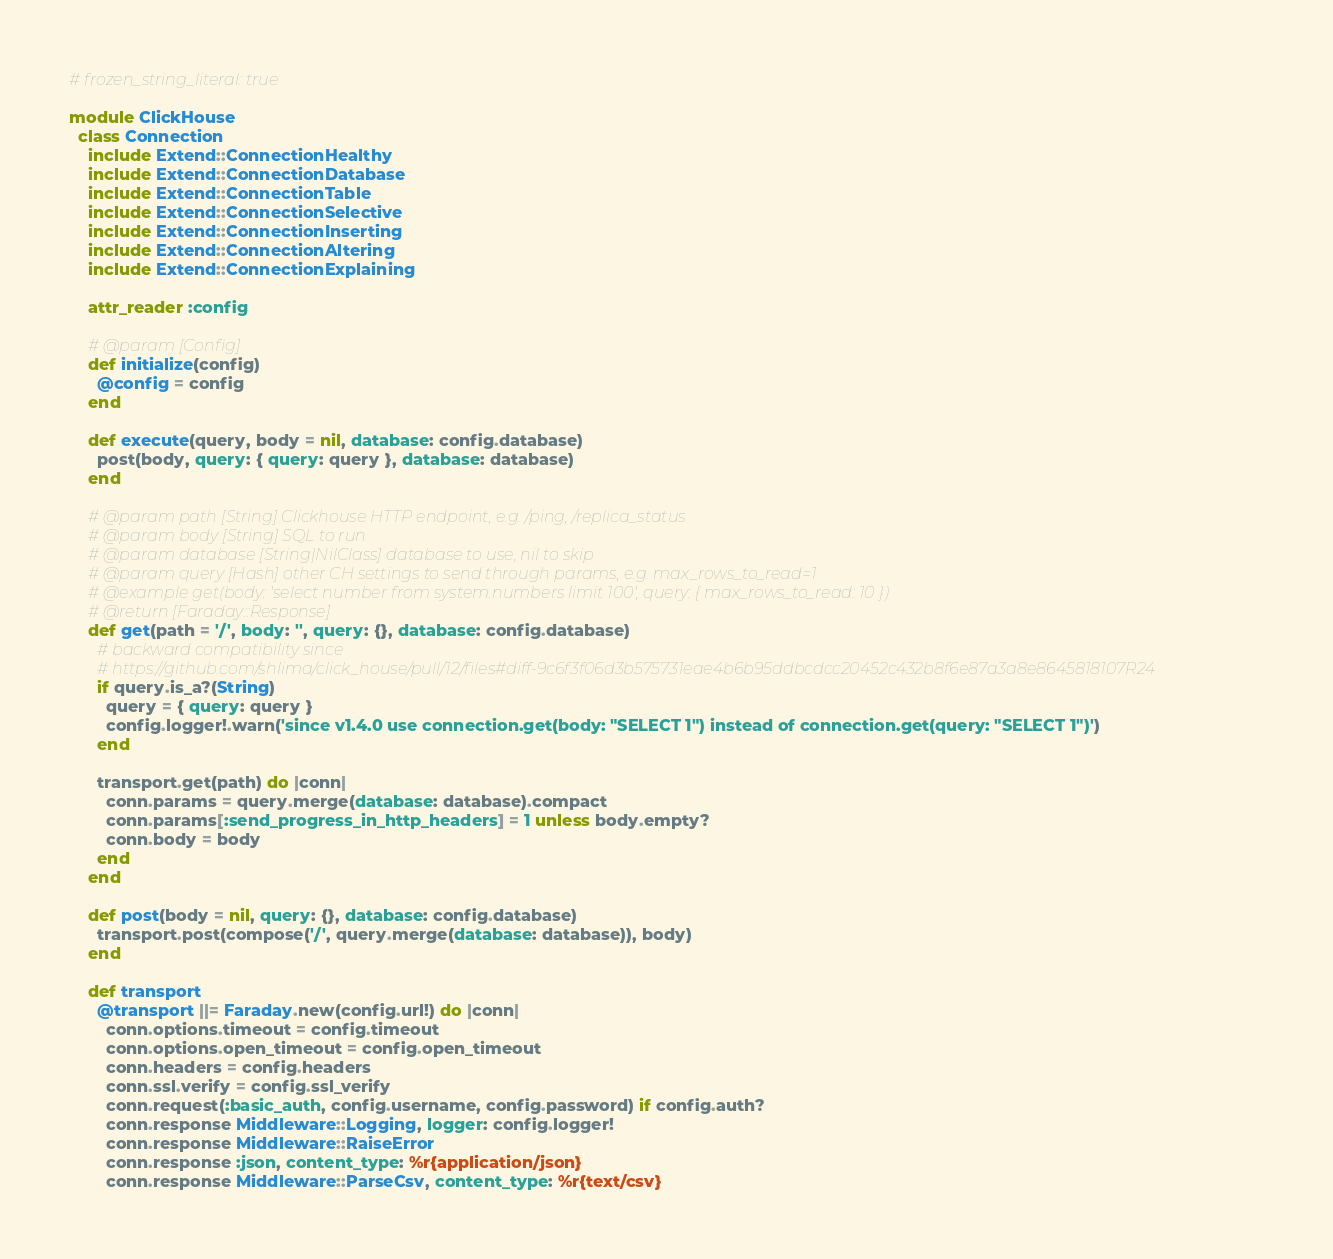<code> <loc_0><loc_0><loc_500><loc_500><_Ruby_># frozen_string_literal: true

module ClickHouse
  class Connection
    include Extend::ConnectionHealthy
    include Extend::ConnectionDatabase
    include Extend::ConnectionTable
    include Extend::ConnectionSelective
    include Extend::ConnectionInserting
    include Extend::ConnectionAltering
    include Extend::ConnectionExplaining

    attr_reader :config

    # @param [Config]
    def initialize(config)
      @config = config
    end

    def execute(query, body = nil, database: config.database)
      post(body, query: { query: query }, database: database)
    end

    # @param path [String] Clickhouse HTTP endpoint, e.g. /ping, /replica_status
    # @param body [String] SQL to run
    # @param database [String|NilClass] database to use, nil to skip
    # @param query [Hash] other CH settings to send through params, e.g. max_rows_to_read=1
    # @example get(body: 'select number from system.numbers limit 100', query: { max_rows_to_read: 10 })
    # @return [Faraday::Response]
    def get(path = '/', body: '', query: {}, database: config.database)
      # backward compatibility since
      # https://github.com/shlima/click_house/pull/12/files#diff-9c6f3f06d3b575731eae4b6b95ddbcdcc20452c432b8f6e87a3a8e8645818107R24
      if query.is_a?(String)
        query = { query: query }
        config.logger!.warn('since v1.4.0 use connection.get(body: "SELECT 1") instead of connection.get(query: "SELECT 1")')
      end

      transport.get(path) do |conn|
        conn.params = query.merge(database: database).compact
        conn.params[:send_progress_in_http_headers] = 1 unless body.empty?
        conn.body = body
      end
    end

    def post(body = nil, query: {}, database: config.database)
      transport.post(compose('/', query.merge(database: database)), body)
    end

    def transport
      @transport ||= Faraday.new(config.url!) do |conn|
        conn.options.timeout = config.timeout
        conn.options.open_timeout = config.open_timeout
        conn.headers = config.headers
        conn.ssl.verify = config.ssl_verify
        conn.request(:basic_auth, config.username, config.password) if config.auth?
        conn.response Middleware::Logging, logger: config.logger!
        conn.response Middleware::RaiseError
        conn.response :json, content_type: %r{application/json}
        conn.response Middleware::ParseCsv, content_type: %r{text/csv}</code> 